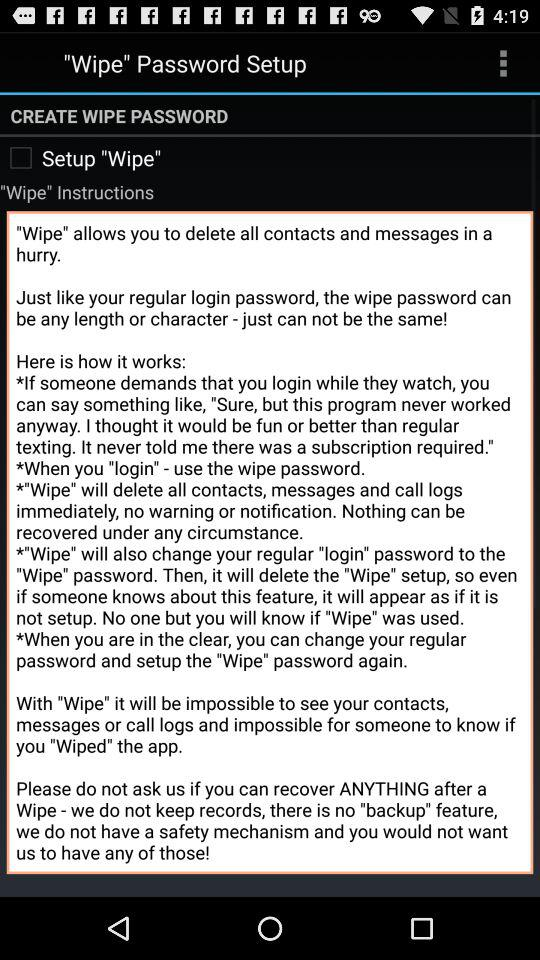Which password do you need to use for login?
When the provided information is insufficient, respond with <no answer>. <no answer> 